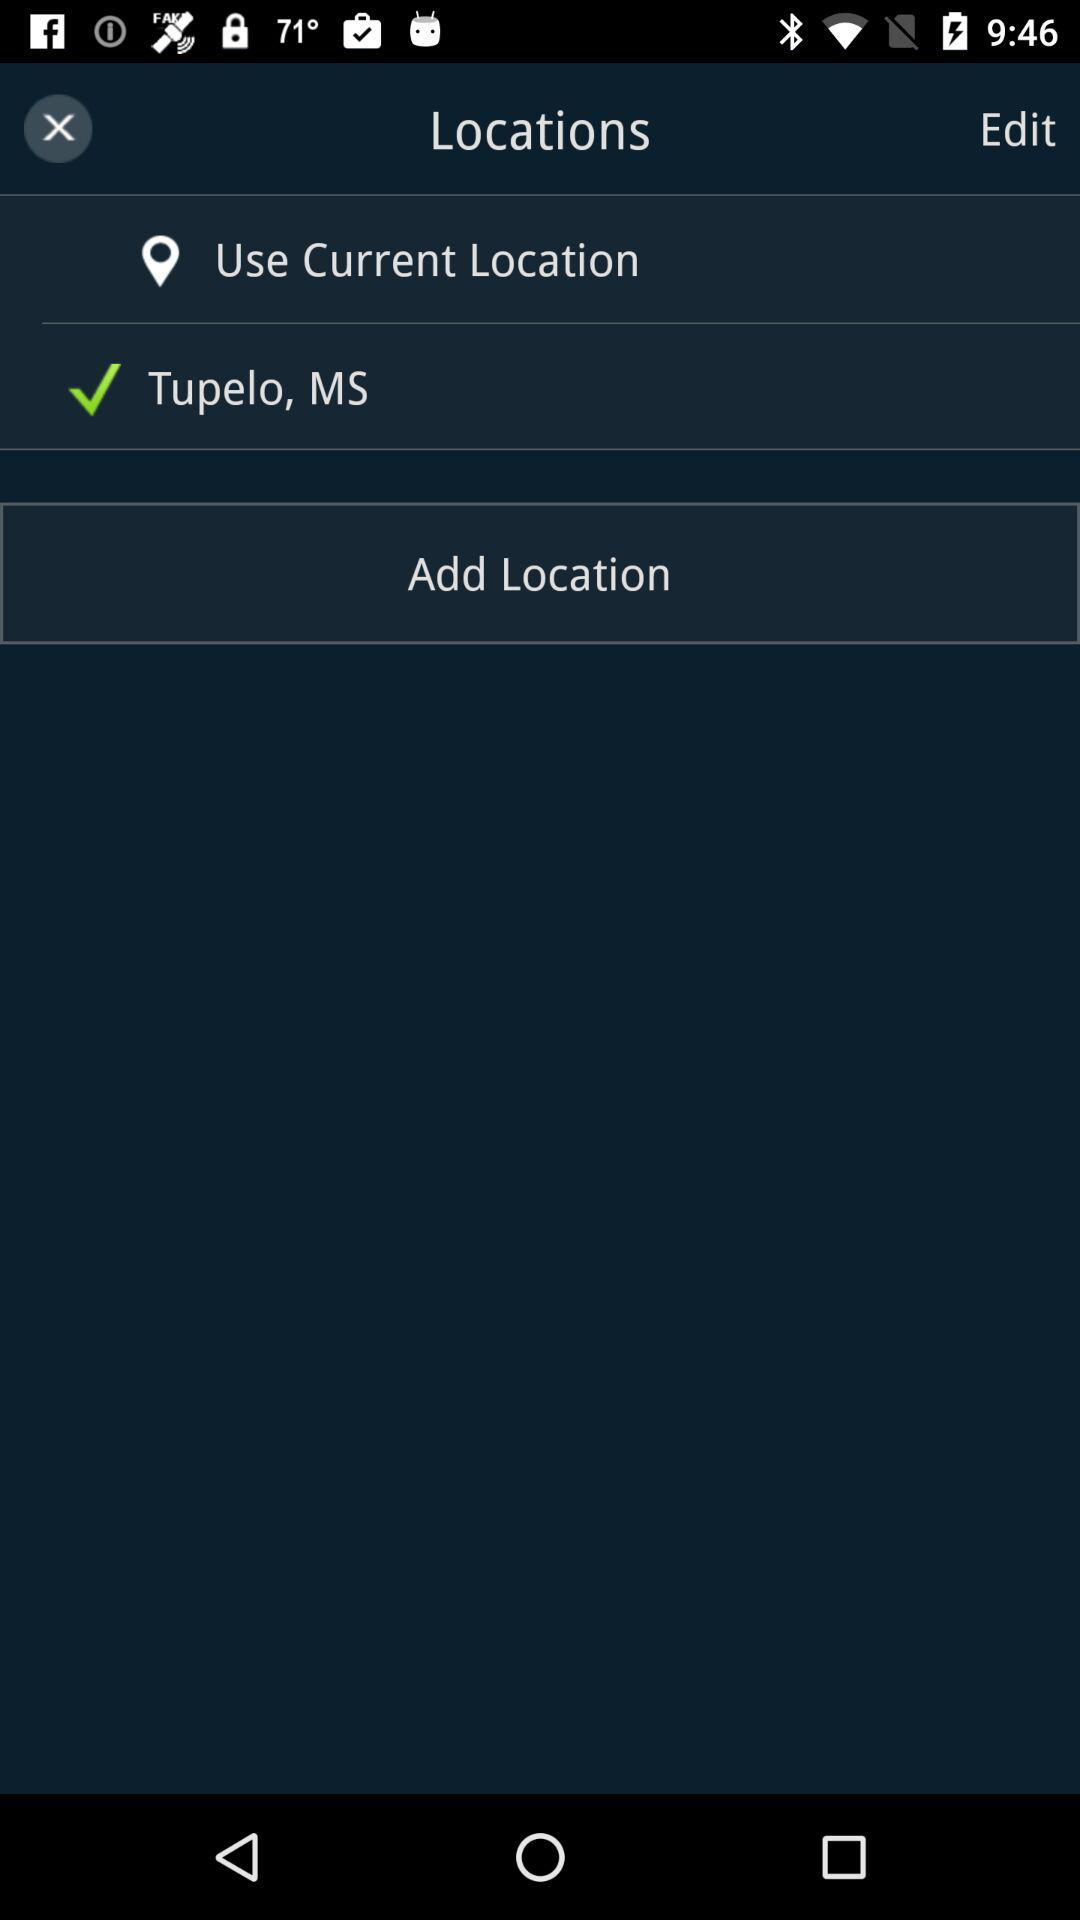How many locations are there with a checkmark?
Answer the question using a single word or phrase. 1 